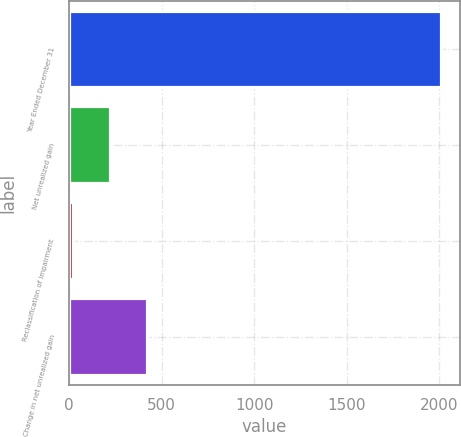Convert chart to OTSL. <chart><loc_0><loc_0><loc_500><loc_500><bar_chart><fcel>Year Ended December 31<fcel>Net unrealized gain<fcel>Reclassification of impairment<fcel>Change in net unrealized gain<nl><fcel>2010<fcel>220.8<fcel>22<fcel>419.6<nl></chart> 